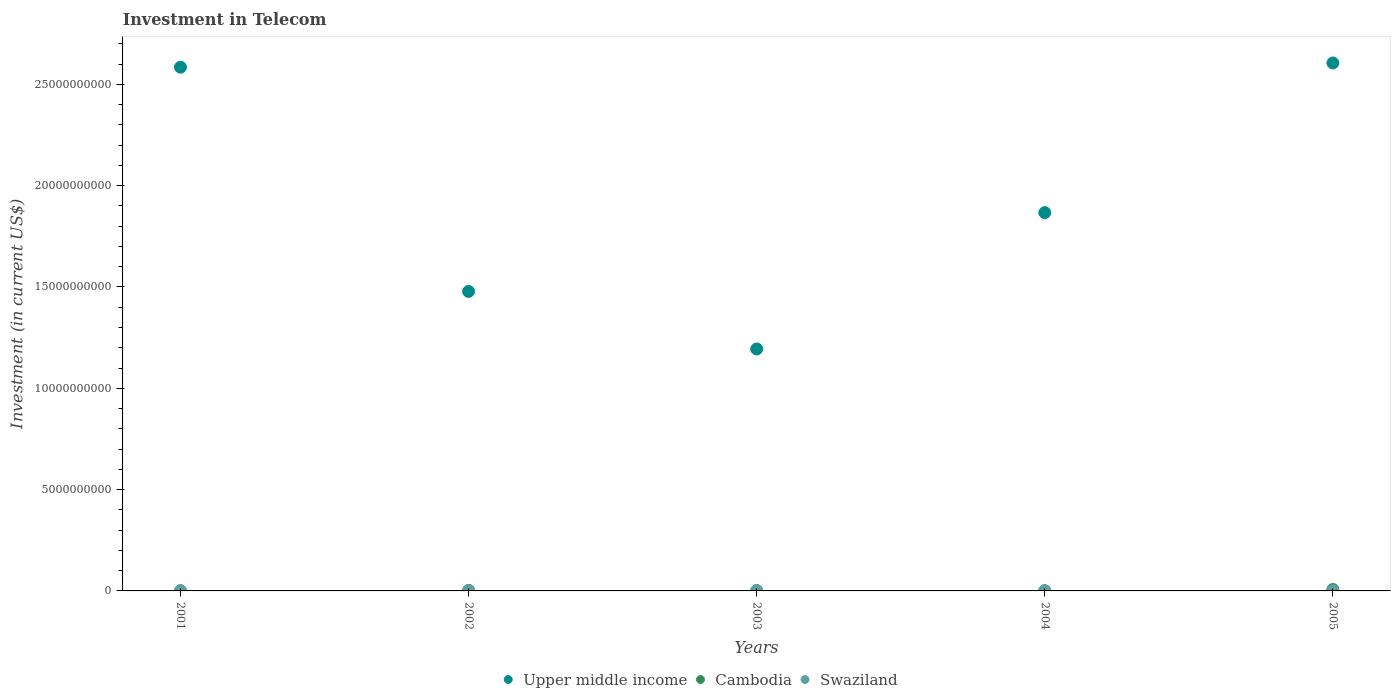Is the number of dotlines equal to the number of legend labels?
Your answer should be compact. Yes. What is the amount invested in telecom in Upper middle income in 2002?
Provide a short and direct response. 1.48e+1. Across all years, what is the maximum amount invested in telecom in Swaziland?
Your answer should be very brief. 9.30e+06. Across all years, what is the minimum amount invested in telecom in Swaziland?
Provide a short and direct response. 2.80e+06. In which year was the amount invested in telecom in Upper middle income minimum?
Offer a terse response. 2003. What is the total amount invested in telecom in Upper middle income in the graph?
Provide a succinct answer. 9.73e+1. What is the difference between the amount invested in telecom in Cambodia in 2002 and that in 2004?
Your response must be concise. 2.09e+07. What is the difference between the amount invested in telecom in Upper middle income in 2004 and the amount invested in telecom in Swaziland in 2001?
Your response must be concise. 1.87e+1. What is the average amount invested in telecom in Cambodia per year?
Ensure brevity in your answer.  2.67e+07. In the year 2002, what is the difference between the amount invested in telecom in Upper middle income and amount invested in telecom in Swaziland?
Provide a succinct answer. 1.48e+1. What is the ratio of the amount invested in telecom in Upper middle income in 2001 to that in 2003?
Offer a terse response. 2.16. Is the amount invested in telecom in Cambodia in 2004 less than that in 2005?
Give a very brief answer. Yes. Is the difference between the amount invested in telecom in Upper middle income in 2001 and 2005 greater than the difference between the amount invested in telecom in Swaziland in 2001 and 2005?
Offer a very short reply. No. What is the difference between the highest and the second highest amount invested in telecom in Cambodia?
Your answer should be compact. 4.04e+07. What is the difference between the highest and the lowest amount invested in telecom in Cambodia?
Ensure brevity in your answer.  6.13e+07. In how many years, is the amount invested in telecom in Upper middle income greater than the average amount invested in telecom in Upper middle income taken over all years?
Your answer should be compact. 2. Is the sum of the amount invested in telecom in Cambodia in 2001 and 2003 greater than the maximum amount invested in telecom in Upper middle income across all years?
Offer a very short reply. No. Is it the case that in every year, the sum of the amount invested in telecom in Upper middle income and amount invested in telecom in Swaziland  is greater than the amount invested in telecom in Cambodia?
Offer a terse response. Yes. Does the amount invested in telecom in Upper middle income monotonically increase over the years?
Your response must be concise. No. Is the amount invested in telecom in Upper middle income strictly greater than the amount invested in telecom in Swaziland over the years?
Offer a very short reply. Yes. Does the graph contain any zero values?
Offer a very short reply. No. Where does the legend appear in the graph?
Your response must be concise. Bottom center. What is the title of the graph?
Ensure brevity in your answer.  Investment in Telecom. What is the label or title of the Y-axis?
Give a very brief answer. Investment (in current US$). What is the Investment (in current US$) in Upper middle income in 2001?
Your response must be concise. 2.58e+1. What is the Investment (in current US$) in Swaziland in 2001?
Your answer should be compact. 2.80e+06. What is the Investment (in current US$) of Upper middle income in 2002?
Keep it short and to the point. 1.48e+1. What is the Investment (in current US$) in Cambodia in 2002?
Your answer should be compact. 2.84e+07. What is the Investment (in current US$) of Swaziland in 2002?
Offer a terse response. 4.20e+06. What is the Investment (in current US$) of Upper middle income in 2003?
Provide a short and direct response. 1.19e+1. What is the Investment (in current US$) of Cambodia in 2003?
Provide a short and direct response. 1.70e+07. What is the Investment (in current US$) in Swaziland in 2003?
Your answer should be very brief. 3.00e+06. What is the Investment (in current US$) of Upper middle income in 2004?
Keep it short and to the point. 1.87e+1. What is the Investment (in current US$) in Cambodia in 2004?
Your answer should be compact. 7.50e+06. What is the Investment (in current US$) of Swaziland in 2004?
Provide a succinct answer. 9.30e+06. What is the Investment (in current US$) of Upper middle income in 2005?
Your response must be concise. 2.61e+1. What is the Investment (in current US$) in Cambodia in 2005?
Your response must be concise. 6.88e+07. What is the Investment (in current US$) in Swaziland in 2005?
Your response must be concise. 3.00e+06. Across all years, what is the maximum Investment (in current US$) in Upper middle income?
Make the answer very short. 2.61e+1. Across all years, what is the maximum Investment (in current US$) of Cambodia?
Ensure brevity in your answer.  6.88e+07. Across all years, what is the maximum Investment (in current US$) of Swaziland?
Your answer should be very brief. 9.30e+06. Across all years, what is the minimum Investment (in current US$) of Upper middle income?
Give a very brief answer. 1.19e+1. Across all years, what is the minimum Investment (in current US$) of Cambodia?
Your response must be concise. 7.50e+06. Across all years, what is the minimum Investment (in current US$) of Swaziland?
Provide a succinct answer. 2.80e+06. What is the total Investment (in current US$) in Upper middle income in the graph?
Your answer should be very brief. 9.73e+1. What is the total Investment (in current US$) of Cambodia in the graph?
Offer a very short reply. 1.34e+08. What is the total Investment (in current US$) in Swaziland in the graph?
Offer a very short reply. 2.23e+07. What is the difference between the Investment (in current US$) of Upper middle income in 2001 and that in 2002?
Your answer should be compact. 1.11e+1. What is the difference between the Investment (in current US$) of Cambodia in 2001 and that in 2002?
Your answer should be compact. -1.64e+07. What is the difference between the Investment (in current US$) of Swaziland in 2001 and that in 2002?
Offer a very short reply. -1.40e+06. What is the difference between the Investment (in current US$) of Upper middle income in 2001 and that in 2003?
Offer a very short reply. 1.39e+1. What is the difference between the Investment (in current US$) in Cambodia in 2001 and that in 2003?
Provide a short and direct response. -5.00e+06. What is the difference between the Investment (in current US$) in Upper middle income in 2001 and that in 2004?
Provide a succinct answer. 7.18e+09. What is the difference between the Investment (in current US$) of Cambodia in 2001 and that in 2004?
Provide a succinct answer. 4.50e+06. What is the difference between the Investment (in current US$) in Swaziland in 2001 and that in 2004?
Your answer should be very brief. -6.50e+06. What is the difference between the Investment (in current US$) in Upper middle income in 2001 and that in 2005?
Offer a terse response. -2.09e+08. What is the difference between the Investment (in current US$) in Cambodia in 2001 and that in 2005?
Offer a terse response. -5.68e+07. What is the difference between the Investment (in current US$) in Upper middle income in 2002 and that in 2003?
Offer a very short reply. 2.84e+09. What is the difference between the Investment (in current US$) of Cambodia in 2002 and that in 2003?
Your answer should be compact. 1.14e+07. What is the difference between the Investment (in current US$) of Swaziland in 2002 and that in 2003?
Provide a succinct answer. 1.20e+06. What is the difference between the Investment (in current US$) of Upper middle income in 2002 and that in 2004?
Offer a terse response. -3.89e+09. What is the difference between the Investment (in current US$) of Cambodia in 2002 and that in 2004?
Your answer should be compact. 2.09e+07. What is the difference between the Investment (in current US$) of Swaziland in 2002 and that in 2004?
Ensure brevity in your answer.  -5.10e+06. What is the difference between the Investment (in current US$) in Upper middle income in 2002 and that in 2005?
Ensure brevity in your answer.  -1.13e+1. What is the difference between the Investment (in current US$) of Cambodia in 2002 and that in 2005?
Your answer should be compact. -4.04e+07. What is the difference between the Investment (in current US$) of Swaziland in 2002 and that in 2005?
Offer a very short reply. 1.20e+06. What is the difference between the Investment (in current US$) in Upper middle income in 2003 and that in 2004?
Give a very brief answer. -6.73e+09. What is the difference between the Investment (in current US$) in Cambodia in 2003 and that in 2004?
Give a very brief answer. 9.50e+06. What is the difference between the Investment (in current US$) of Swaziland in 2003 and that in 2004?
Keep it short and to the point. -6.30e+06. What is the difference between the Investment (in current US$) in Upper middle income in 2003 and that in 2005?
Offer a very short reply. -1.41e+1. What is the difference between the Investment (in current US$) in Cambodia in 2003 and that in 2005?
Your answer should be very brief. -5.18e+07. What is the difference between the Investment (in current US$) in Upper middle income in 2004 and that in 2005?
Offer a very short reply. -7.39e+09. What is the difference between the Investment (in current US$) in Cambodia in 2004 and that in 2005?
Your answer should be compact. -6.13e+07. What is the difference between the Investment (in current US$) of Swaziland in 2004 and that in 2005?
Offer a terse response. 6.30e+06. What is the difference between the Investment (in current US$) of Upper middle income in 2001 and the Investment (in current US$) of Cambodia in 2002?
Ensure brevity in your answer.  2.58e+1. What is the difference between the Investment (in current US$) in Upper middle income in 2001 and the Investment (in current US$) in Swaziland in 2002?
Keep it short and to the point. 2.58e+1. What is the difference between the Investment (in current US$) of Cambodia in 2001 and the Investment (in current US$) of Swaziland in 2002?
Give a very brief answer. 7.80e+06. What is the difference between the Investment (in current US$) in Upper middle income in 2001 and the Investment (in current US$) in Cambodia in 2003?
Keep it short and to the point. 2.58e+1. What is the difference between the Investment (in current US$) in Upper middle income in 2001 and the Investment (in current US$) in Swaziland in 2003?
Your response must be concise. 2.58e+1. What is the difference between the Investment (in current US$) in Cambodia in 2001 and the Investment (in current US$) in Swaziland in 2003?
Your answer should be compact. 9.00e+06. What is the difference between the Investment (in current US$) in Upper middle income in 2001 and the Investment (in current US$) in Cambodia in 2004?
Give a very brief answer. 2.58e+1. What is the difference between the Investment (in current US$) in Upper middle income in 2001 and the Investment (in current US$) in Swaziland in 2004?
Offer a very short reply. 2.58e+1. What is the difference between the Investment (in current US$) in Cambodia in 2001 and the Investment (in current US$) in Swaziland in 2004?
Provide a short and direct response. 2.70e+06. What is the difference between the Investment (in current US$) of Upper middle income in 2001 and the Investment (in current US$) of Cambodia in 2005?
Keep it short and to the point. 2.58e+1. What is the difference between the Investment (in current US$) in Upper middle income in 2001 and the Investment (in current US$) in Swaziland in 2005?
Make the answer very short. 2.58e+1. What is the difference between the Investment (in current US$) of Cambodia in 2001 and the Investment (in current US$) of Swaziland in 2005?
Your answer should be compact. 9.00e+06. What is the difference between the Investment (in current US$) of Upper middle income in 2002 and the Investment (in current US$) of Cambodia in 2003?
Your answer should be compact. 1.48e+1. What is the difference between the Investment (in current US$) in Upper middle income in 2002 and the Investment (in current US$) in Swaziland in 2003?
Your answer should be compact. 1.48e+1. What is the difference between the Investment (in current US$) in Cambodia in 2002 and the Investment (in current US$) in Swaziland in 2003?
Keep it short and to the point. 2.54e+07. What is the difference between the Investment (in current US$) in Upper middle income in 2002 and the Investment (in current US$) in Cambodia in 2004?
Ensure brevity in your answer.  1.48e+1. What is the difference between the Investment (in current US$) in Upper middle income in 2002 and the Investment (in current US$) in Swaziland in 2004?
Make the answer very short. 1.48e+1. What is the difference between the Investment (in current US$) in Cambodia in 2002 and the Investment (in current US$) in Swaziland in 2004?
Give a very brief answer. 1.91e+07. What is the difference between the Investment (in current US$) of Upper middle income in 2002 and the Investment (in current US$) of Cambodia in 2005?
Provide a succinct answer. 1.47e+1. What is the difference between the Investment (in current US$) in Upper middle income in 2002 and the Investment (in current US$) in Swaziland in 2005?
Provide a short and direct response. 1.48e+1. What is the difference between the Investment (in current US$) of Cambodia in 2002 and the Investment (in current US$) of Swaziland in 2005?
Offer a terse response. 2.54e+07. What is the difference between the Investment (in current US$) in Upper middle income in 2003 and the Investment (in current US$) in Cambodia in 2004?
Your answer should be compact. 1.19e+1. What is the difference between the Investment (in current US$) in Upper middle income in 2003 and the Investment (in current US$) in Swaziland in 2004?
Give a very brief answer. 1.19e+1. What is the difference between the Investment (in current US$) of Cambodia in 2003 and the Investment (in current US$) of Swaziland in 2004?
Ensure brevity in your answer.  7.70e+06. What is the difference between the Investment (in current US$) of Upper middle income in 2003 and the Investment (in current US$) of Cambodia in 2005?
Offer a terse response. 1.19e+1. What is the difference between the Investment (in current US$) of Upper middle income in 2003 and the Investment (in current US$) of Swaziland in 2005?
Your answer should be very brief. 1.19e+1. What is the difference between the Investment (in current US$) of Cambodia in 2003 and the Investment (in current US$) of Swaziland in 2005?
Give a very brief answer. 1.40e+07. What is the difference between the Investment (in current US$) of Upper middle income in 2004 and the Investment (in current US$) of Cambodia in 2005?
Give a very brief answer. 1.86e+1. What is the difference between the Investment (in current US$) in Upper middle income in 2004 and the Investment (in current US$) in Swaziland in 2005?
Make the answer very short. 1.87e+1. What is the difference between the Investment (in current US$) of Cambodia in 2004 and the Investment (in current US$) of Swaziland in 2005?
Offer a terse response. 4.50e+06. What is the average Investment (in current US$) of Upper middle income per year?
Offer a terse response. 1.95e+1. What is the average Investment (in current US$) of Cambodia per year?
Offer a very short reply. 2.67e+07. What is the average Investment (in current US$) in Swaziland per year?
Your answer should be compact. 4.46e+06. In the year 2001, what is the difference between the Investment (in current US$) of Upper middle income and Investment (in current US$) of Cambodia?
Provide a short and direct response. 2.58e+1. In the year 2001, what is the difference between the Investment (in current US$) of Upper middle income and Investment (in current US$) of Swaziland?
Ensure brevity in your answer.  2.58e+1. In the year 2001, what is the difference between the Investment (in current US$) in Cambodia and Investment (in current US$) in Swaziland?
Make the answer very short. 9.20e+06. In the year 2002, what is the difference between the Investment (in current US$) in Upper middle income and Investment (in current US$) in Cambodia?
Provide a succinct answer. 1.48e+1. In the year 2002, what is the difference between the Investment (in current US$) of Upper middle income and Investment (in current US$) of Swaziland?
Provide a short and direct response. 1.48e+1. In the year 2002, what is the difference between the Investment (in current US$) in Cambodia and Investment (in current US$) in Swaziland?
Make the answer very short. 2.42e+07. In the year 2003, what is the difference between the Investment (in current US$) of Upper middle income and Investment (in current US$) of Cambodia?
Make the answer very short. 1.19e+1. In the year 2003, what is the difference between the Investment (in current US$) in Upper middle income and Investment (in current US$) in Swaziland?
Provide a short and direct response. 1.19e+1. In the year 2003, what is the difference between the Investment (in current US$) of Cambodia and Investment (in current US$) of Swaziland?
Ensure brevity in your answer.  1.40e+07. In the year 2004, what is the difference between the Investment (in current US$) of Upper middle income and Investment (in current US$) of Cambodia?
Provide a short and direct response. 1.87e+1. In the year 2004, what is the difference between the Investment (in current US$) of Upper middle income and Investment (in current US$) of Swaziland?
Your answer should be compact. 1.87e+1. In the year 2004, what is the difference between the Investment (in current US$) of Cambodia and Investment (in current US$) of Swaziland?
Ensure brevity in your answer.  -1.80e+06. In the year 2005, what is the difference between the Investment (in current US$) of Upper middle income and Investment (in current US$) of Cambodia?
Provide a short and direct response. 2.60e+1. In the year 2005, what is the difference between the Investment (in current US$) of Upper middle income and Investment (in current US$) of Swaziland?
Your answer should be compact. 2.61e+1. In the year 2005, what is the difference between the Investment (in current US$) of Cambodia and Investment (in current US$) of Swaziland?
Your answer should be compact. 6.58e+07. What is the ratio of the Investment (in current US$) of Upper middle income in 2001 to that in 2002?
Offer a terse response. 1.75. What is the ratio of the Investment (in current US$) of Cambodia in 2001 to that in 2002?
Your response must be concise. 0.42. What is the ratio of the Investment (in current US$) in Swaziland in 2001 to that in 2002?
Make the answer very short. 0.67. What is the ratio of the Investment (in current US$) of Upper middle income in 2001 to that in 2003?
Your response must be concise. 2.16. What is the ratio of the Investment (in current US$) of Cambodia in 2001 to that in 2003?
Make the answer very short. 0.71. What is the ratio of the Investment (in current US$) in Upper middle income in 2001 to that in 2004?
Offer a terse response. 1.38. What is the ratio of the Investment (in current US$) in Cambodia in 2001 to that in 2004?
Your answer should be very brief. 1.6. What is the ratio of the Investment (in current US$) of Swaziland in 2001 to that in 2004?
Make the answer very short. 0.3. What is the ratio of the Investment (in current US$) of Upper middle income in 2001 to that in 2005?
Your response must be concise. 0.99. What is the ratio of the Investment (in current US$) of Cambodia in 2001 to that in 2005?
Offer a very short reply. 0.17. What is the ratio of the Investment (in current US$) of Upper middle income in 2002 to that in 2003?
Keep it short and to the point. 1.24. What is the ratio of the Investment (in current US$) in Cambodia in 2002 to that in 2003?
Make the answer very short. 1.67. What is the ratio of the Investment (in current US$) of Upper middle income in 2002 to that in 2004?
Ensure brevity in your answer.  0.79. What is the ratio of the Investment (in current US$) in Cambodia in 2002 to that in 2004?
Your answer should be very brief. 3.78. What is the ratio of the Investment (in current US$) in Swaziland in 2002 to that in 2004?
Offer a terse response. 0.45. What is the ratio of the Investment (in current US$) in Upper middle income in 2002 to that in 2005?
Keep it short and to the point. 0.57. What is the ratio of the Investment (in current US$) in Cambodia in 2002 to that in 2005?
Offer a very short reply. 0.41. What is the ratio of the Investment (in current US$) in Upper middle income in 2003 to that in 2004?
Offer a terse response. 0.64. What is the ratio of the Investment (in current US$) in Cambodia in 2003 to that in 2004?
Ensure brevity in your answer.  2.27. What is the ratio of the Investment (in current US$) in Swaziland in 2003 to that in 2004?
Make the answer very short. 0.32. What is the ratio of the Investment (in current US$) of Upper middle income in 2003 to that in 2005?
Provide a succinct answer. 0.46. What is the ratio of the Investment (in current US$) of Cambodia in 2003 to that in 2005?
Offer a terse response. 0.25. What is the ratio of the Investment (in current US$) of Upper middle income in 2004 to that in 2005?
Offer a very short reply. 0.72. What is the ratio of the Investment (in current US$) of Cambodia in 2004 to that in 2005?
Keep it short and to the point. 0.11. What is the difference between the highest and the second highest Investment (in current US$) in Upper middle income?
Give a very brief answer. 2.09e+08. What is the difference between the highest and the second highest Investment (in current US$) of Cambodia?
Offer a very short reply. 4.04e+07. What is the difference between the highest and the second highest Investment (in current US$) of Swaziland?
Your response must be concise. 5.10e+06. What is the difference between the highest and the lowest Investment (in current US$) of Upper middle income?
Offer a very short reply. 1.41e+1. What is the difference between the highest and the lowest Investment (in current US$) in Cambodia?
Keep it short and to the point. 6.13e+07. What is the difference between the highest and the lowest Investment (in current US$) in Swaziland?
Provide a succinct answer. 6.50e+06. 